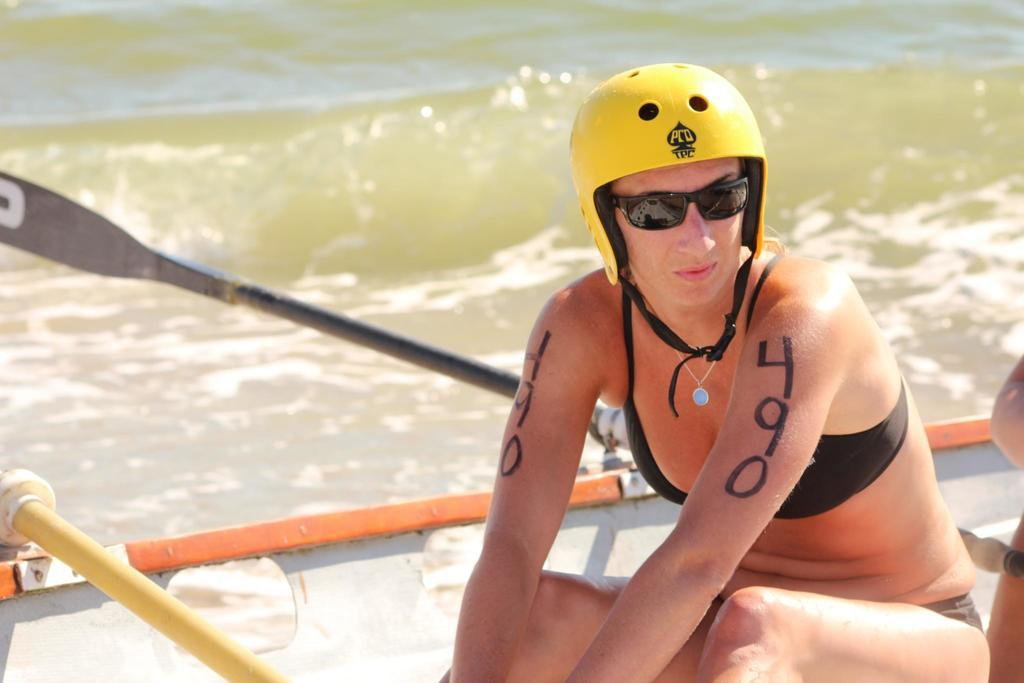What is the person in the boat doing? The person is sitting in the boat. What is the person wearing on their head? The person is wearing a yellow helmet. What are the paddles used for in the boat? The paddles are used for propelling the boat through the water. Where is the boat located? The boat is on the water. What type of bike is the person riding in the image? There is no bike present in the image; the person is sitting in a boat on the water. 